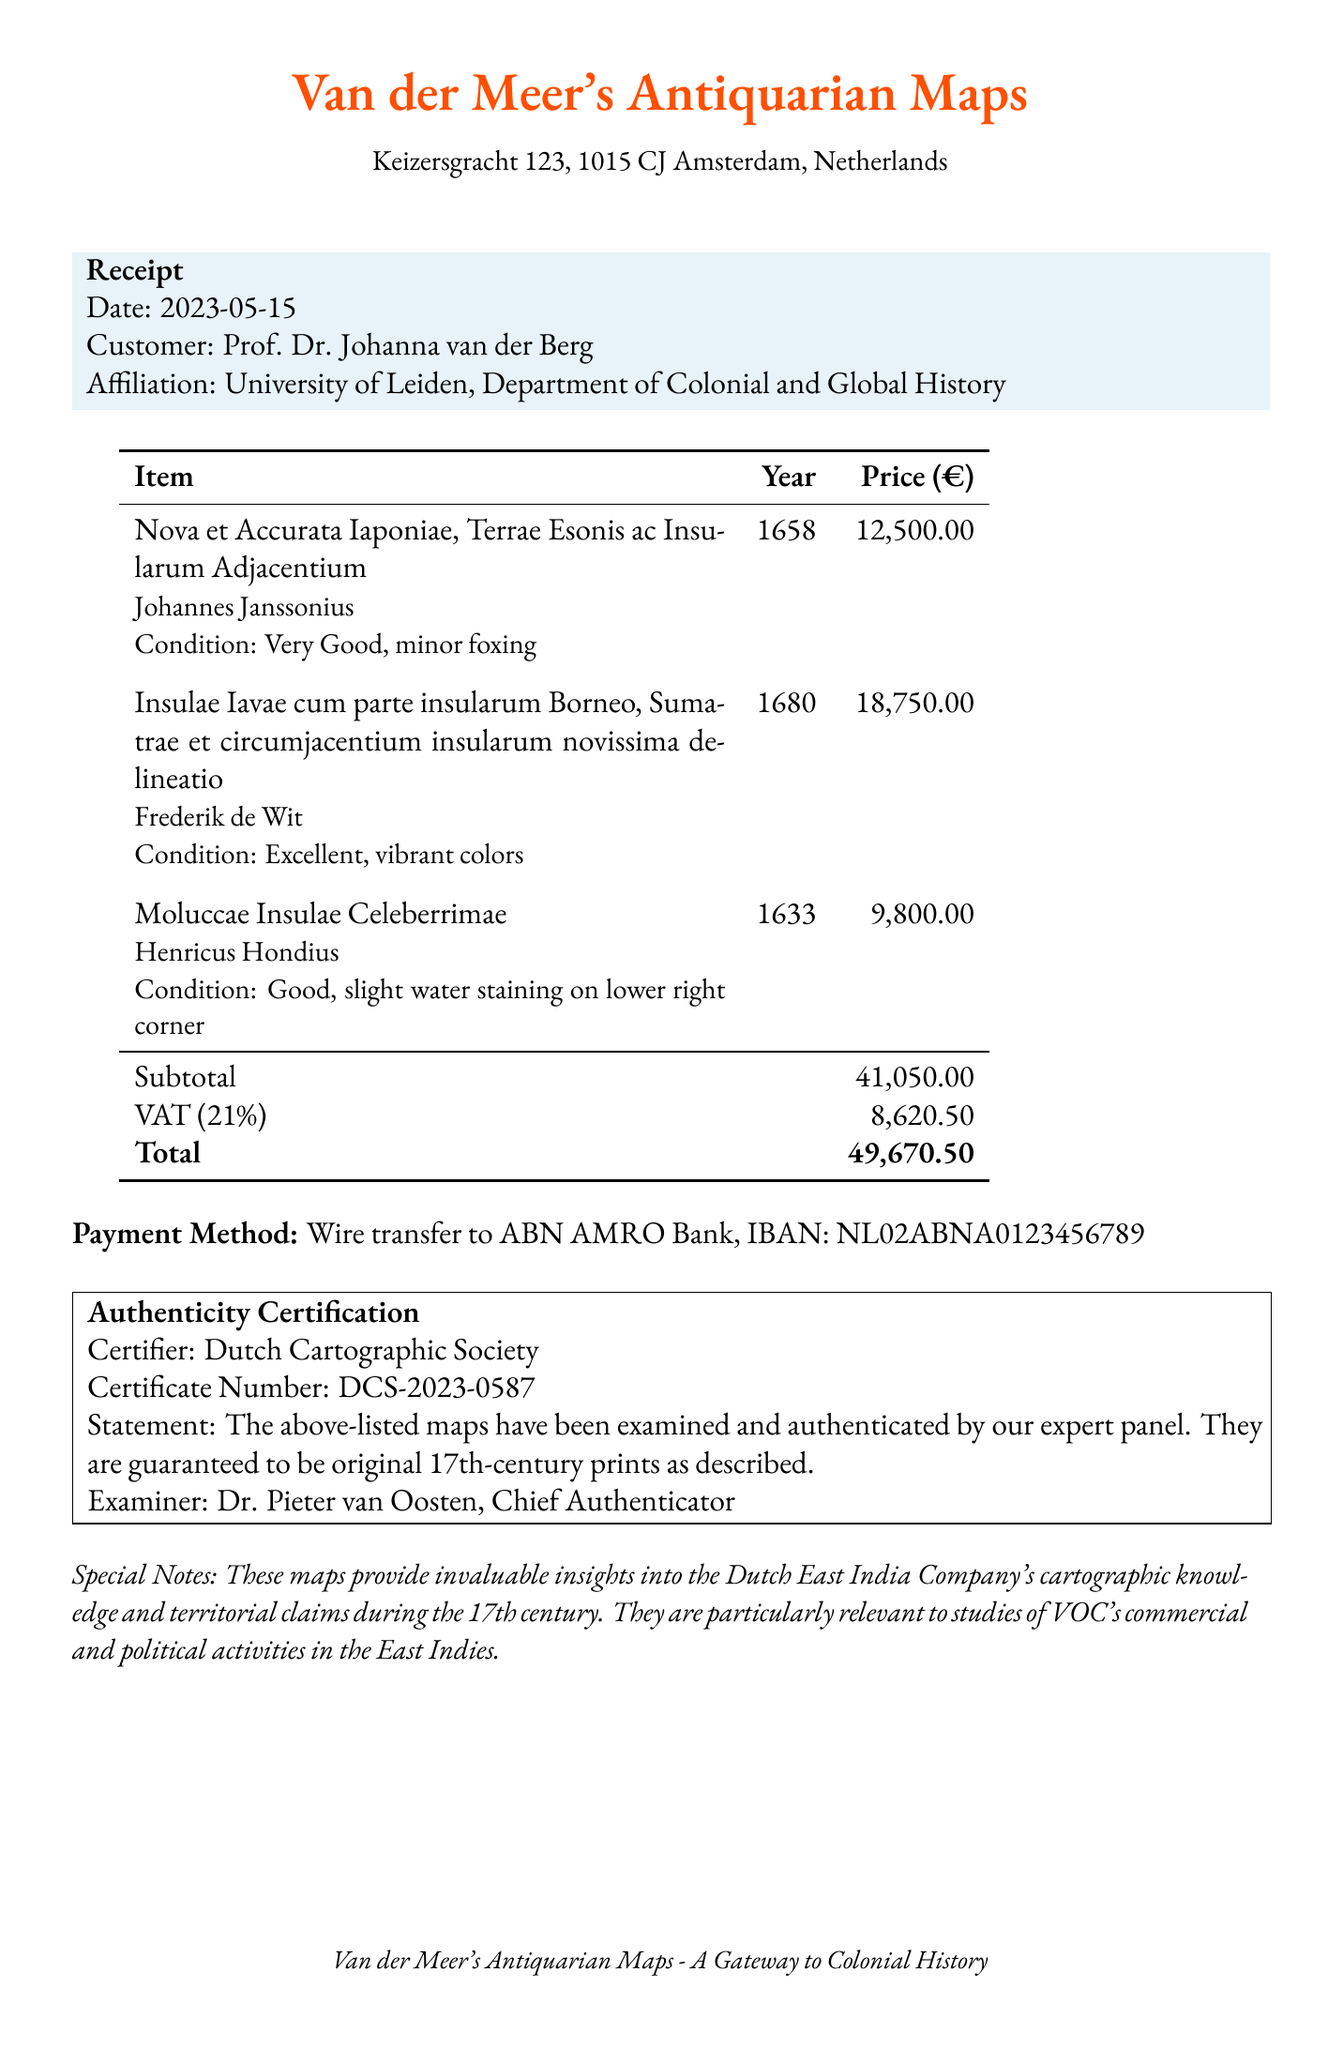What is the store's name? The store's name is explicitly stated at the top of the document.
Answer: Van der Meer's Antiquarian Maps Who is the customer? The customer's name is mentioned in the header section of the receipt.
Answer: Prof. Dr. Johanna van der Berg What is the total amount paid? The total amount paid is the final figure displayed at the bottom of the itemized prices.
Answer: 49,670.50 What is the condition of the map by Johannes Janssonius? The condition of the map is provided under the specific item description in the document.
Answer: Very Good, minor foxing How many items were purchased in total? The receipt lists the number of individual maps purchased.
Answer: 3 What is the VAT percentage applied to the transaction? The VAT percentage is noted next to the calculated VAT amount in the document.
Answer: 21% Who authenticated the maps? The name of the certifier or examiner is clearly mentioned in the authenticity certification section.
Answer: Dutch Cartographic Society What is the certificate number for the authenticity certification? The certificate number is specified in the authenticity section on the receipt.
Answer: DCS-2023-0587 What payment method was used? The payment method is described in a specific line of the document.
Answer: Wire transfer to ABN AMRO Bank 